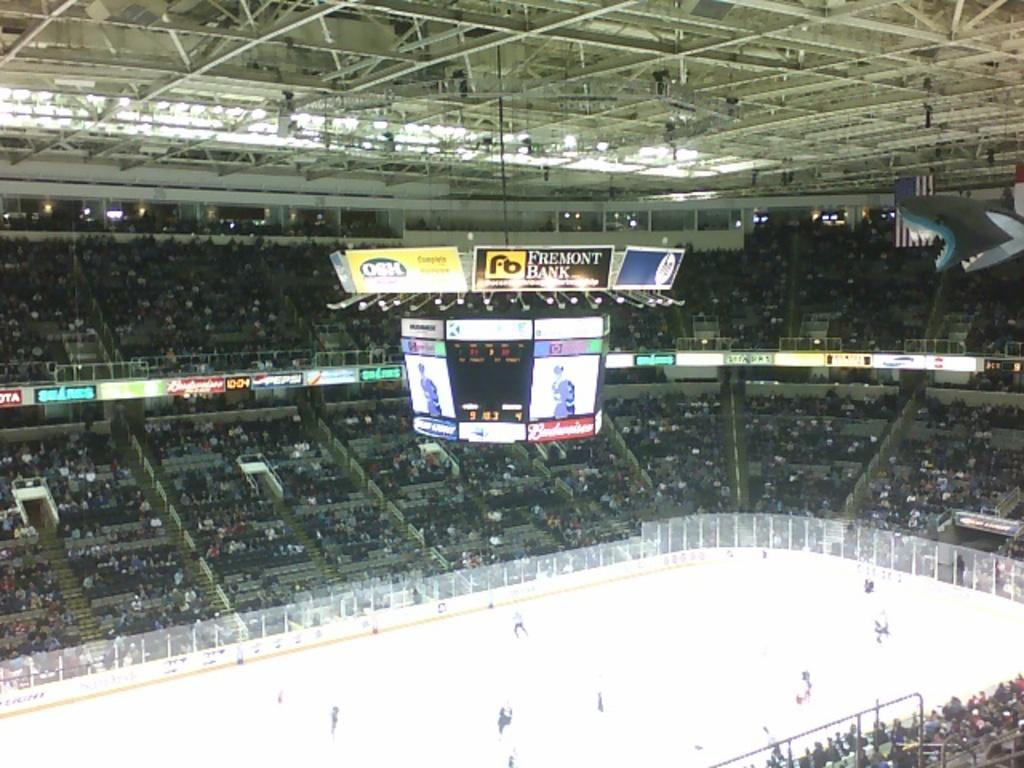<image>
Render a clear and concise summary of the photo. A Fremont Bank ad is on top of the scoreboard above the hockey rink. 